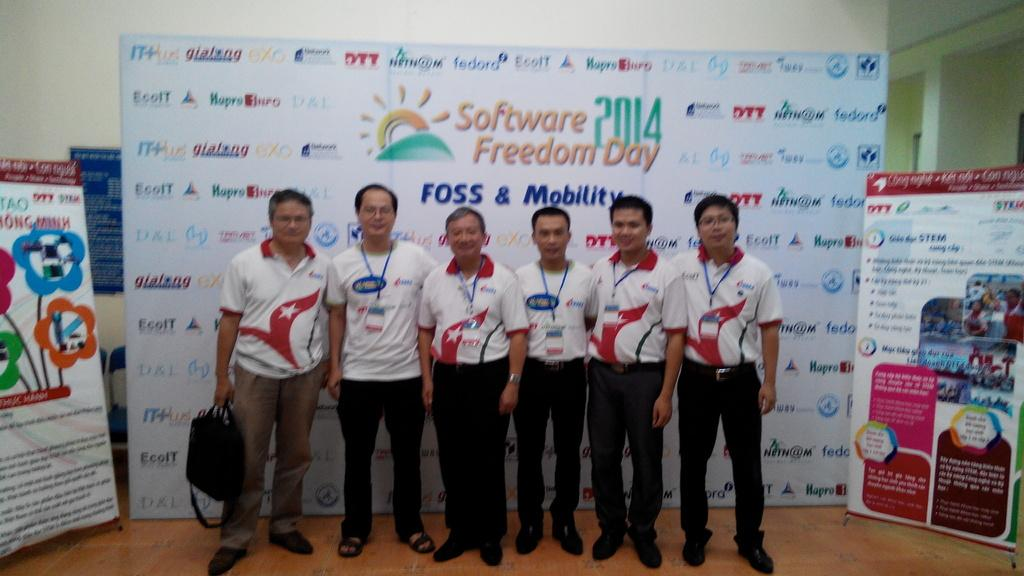Provide a one-sentence caption for the provided image. Group of men taking a picture in front of a board that says "Software Freedom Day". 